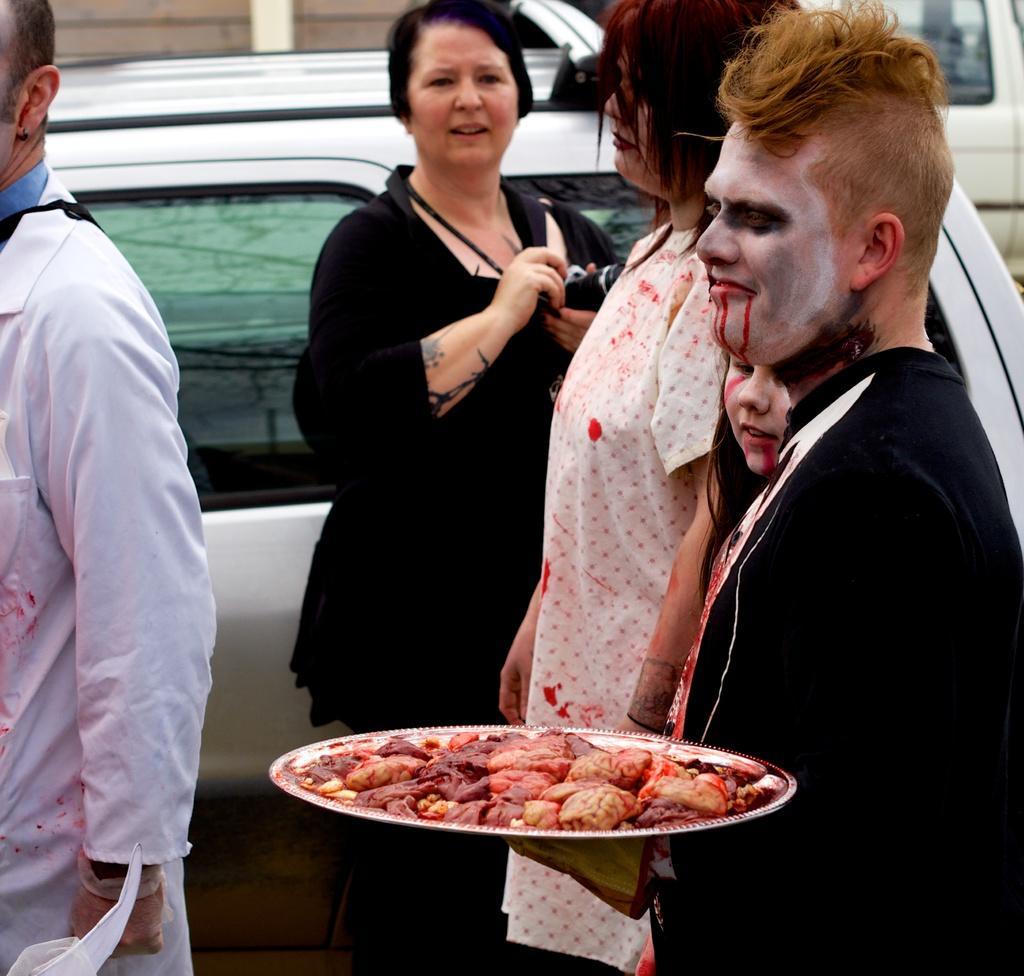Please provide a concise description of this image. There are some people. Person on the right is holding a plate with some meat. And he is having a painting on the face. Lady in the black dress is holding a camera. In the back there are vehicles. 